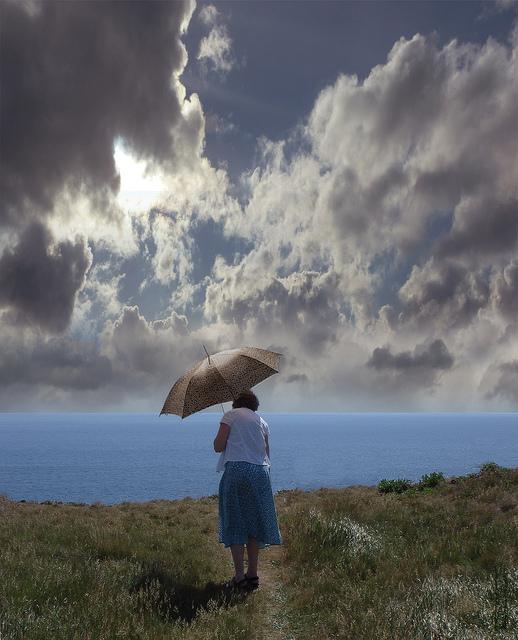Are the people sightseeing?
Keep it brief. Yes. What type of scene is thus?
Concise answer only. Stormy. How many people are sitting under the umbrella?
Concise answer only. 1. What type of outfit does the woman have on?
Concise answer only. Skirt. How many people are shown?
Be succinct. 1. What time of day is it?
Write a very short answer. Afternoon. What color is the umbrella?
Answer briefly. Brown. Is there a storm brewing?
Quick response, please. Yes. How many umbrellas are there?
Short answer required. 1. Is there any boats in the water?
Answer briefly. No. What is this person standing in front of?
Quick response, please. Ocean. What is in the air?
Keep it brief. Clouds. Should the woman be holding an umbrella?
Concise answer only. Yes. What color are the pants?
Short answer required. Blue. What is she standing in?
Write a very short answer. Field. 